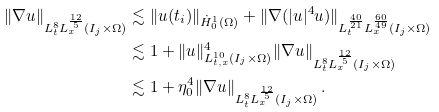Convert formula to latex. <formula><loc_0><loc_0><loc_500><loc_500>\| \nabla u \| _ { L _ { t } ^ { 8 } L _ { x } ^ { \frac { 1 2 } 5 } ( I _ { j } \times \Omega ) } & \lesssim \| u ( t _ { i } ) \| _ { \dot { H } _ { 0 } ^ { 1 } ( \Omega ) } + \| \nabla ( | u | ^ { 4 } u ) \| _ { L _ { t } ^ { \frac { 4 0 } { 2 1 } } L _ { x } ^ { \frac { 6 0 } { 4 9 } } ( I _ { j } \times \Omega ) } \\ & \lesssim 1 + \| u \| _ { L _ { t , x } ^ { 1 0 } ( I _ { j } \times \Omega ) } ^ { 4 } \| \nabla u \| _ { L _ { t } ^ { 8 } L _ { x } ^ { \frac { 1 2 } 5 } ( I _ { j } \times \Omega ) } \\ & \lesssim 1 + \eta _ { 0 } ^ { 4 } \| \nabla u \| _ { L _ { t } ^ { 8 } L _ { x } ^ { \frac { 1 2 } 5 } ( I _ { j } \times \Omega ) } \, .</formula> 